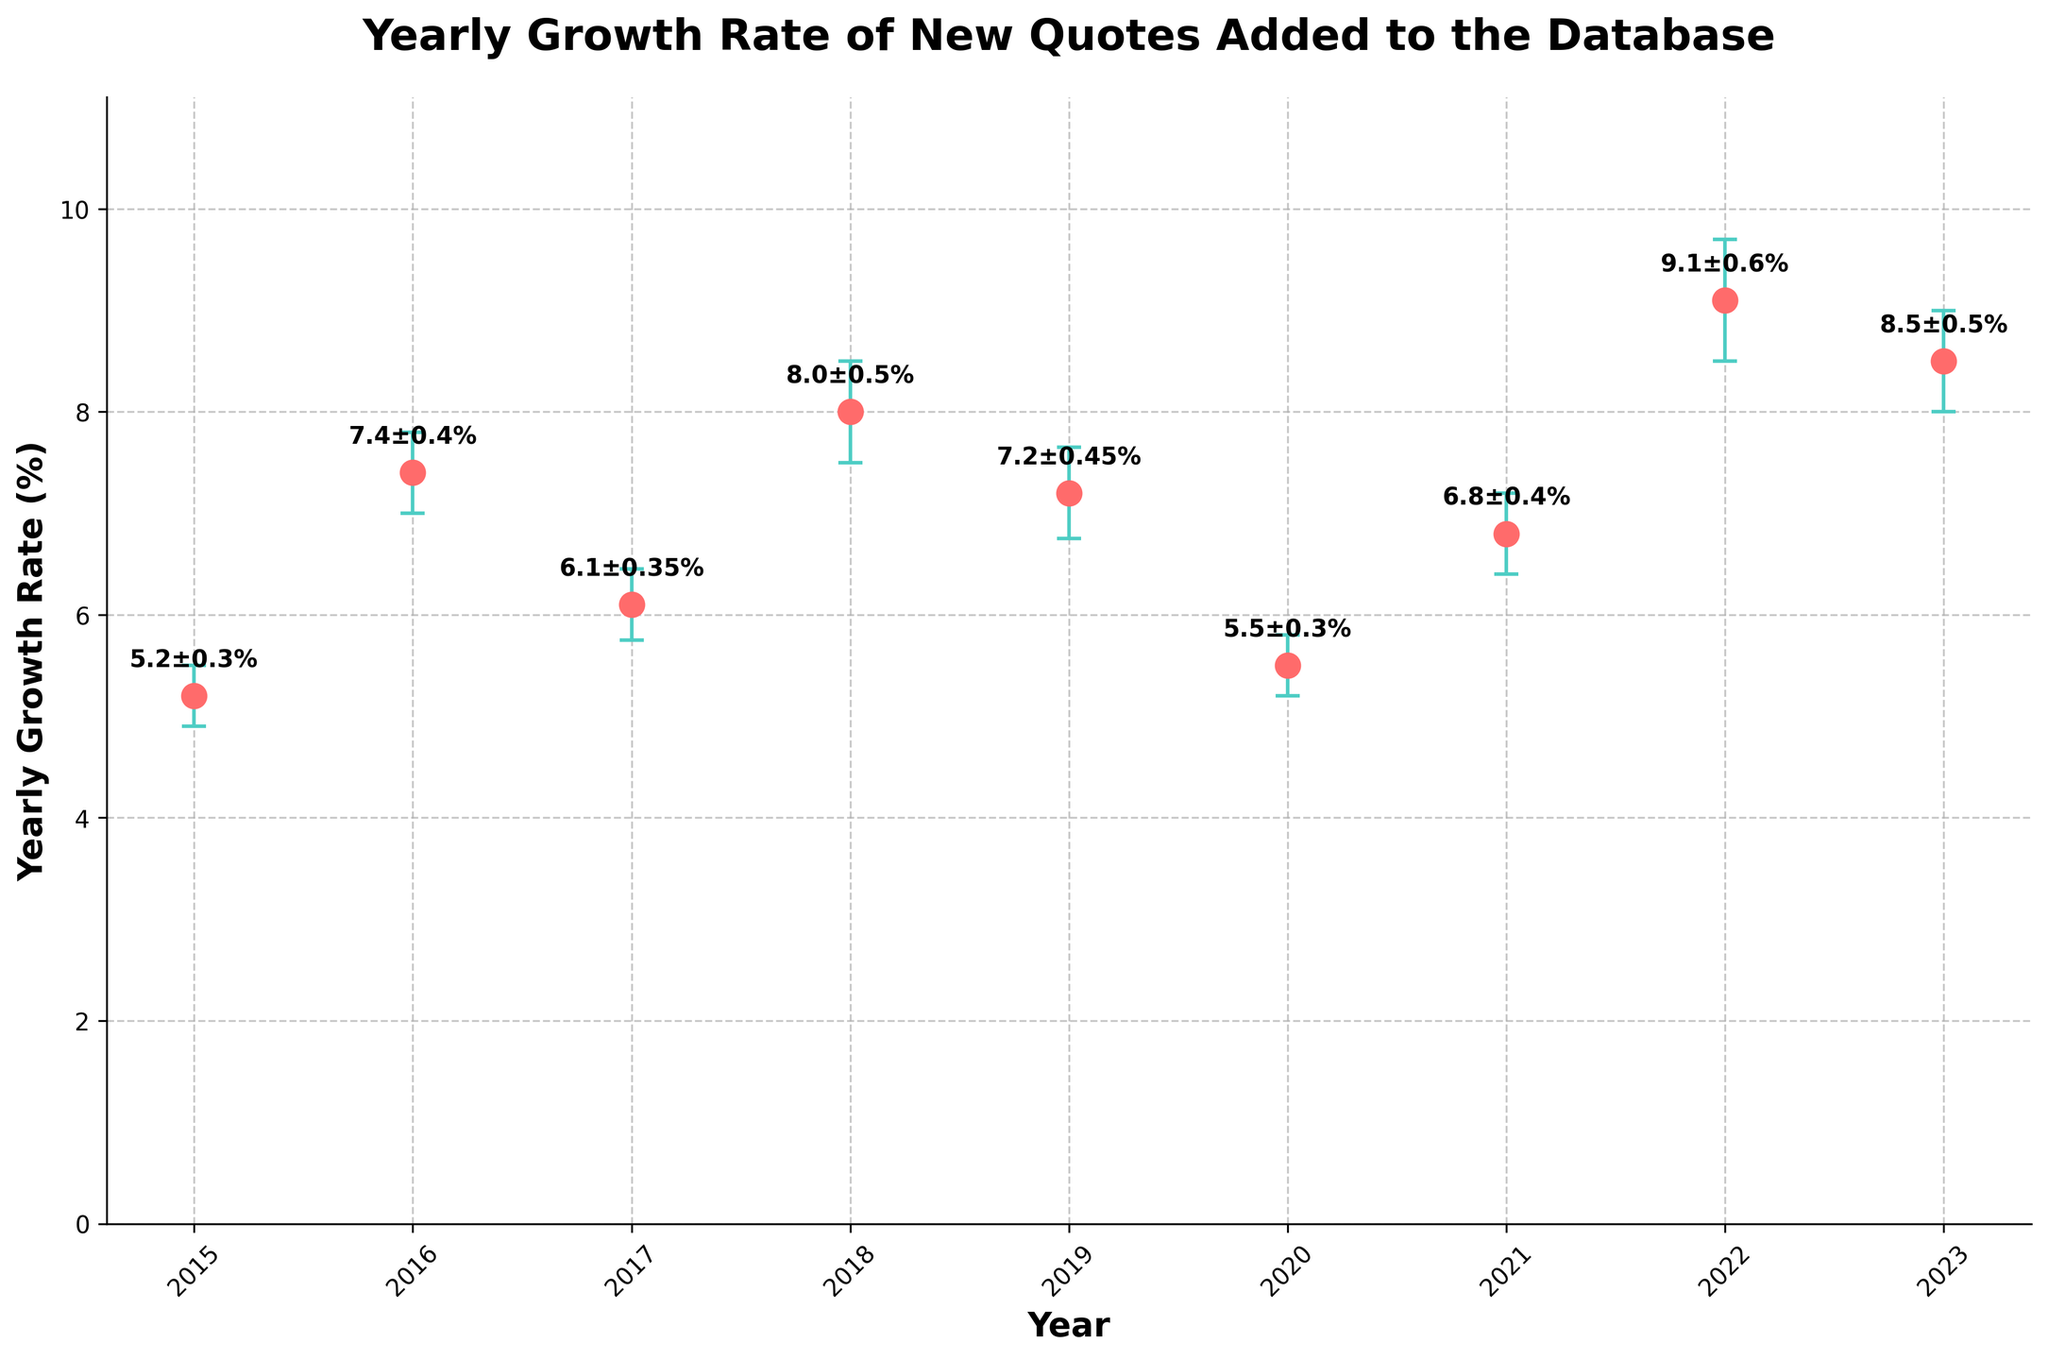What's the title of the figure? The title of the figure is usually displayed at the top of the chart. In this case, it can be seen clearly in large, bold text.
Answer: Yearly Growth Rate of New Quotes Added to the Database What is the yearly growth rate for 2022? To find the yearly growth rate for 2022, look at the data point on the graph that corresponds to the year 2022.
Answer: 9.1% What is the margin of error for 2019? The margin of error for 2019 is indicated by the length of the error bar above and below the point for the year 2019.
Answer: 0.45% Which year experienced the highest growth rate? By comparing the heights of the data points, the highest point indicates the year with the highest growth rate.
Answer: 2022 What is the average yearly growth rate from 2015 to 2023? Sum the yearly growth rates from 2015 to 2023 and then divide by the number of years. (5.2 + 7.4 + 6.1 + 8.0 + 7.2 + 5.5 + 6.8 + 9.1 + 8.5) / 9 = 7.31
Answer: 7.31% How does the growth rate in 2020 compare to that in 2015? To compare the growth rates, subtract the growth rate for 2015 from the growth rate for 2020. 5.5 - 5.2 = 0.3
Answer: 0.3% higher In which year was the margin of error the largest? Look for the longest error bar. The year with the longest error bar has the largest margin of error.
Answer: 2022 What is the range of yearly growth rates from 2015 to 2023? The range is calculated by subtracting the smallest growth rate from the largest growth rate between 2015 and 2023. 9.1 - 5.2 = 3.9
Answer: 3.9% Which years had a growth rate within the margin of error of 7.0%? Check which years have growth rates that, when the margin of error is added or subtracted, include the value 7.0%. 2016 (7.4 ± 0.4), 2019 (7.2 ± 0.45), and 2021 (6.8 ± 0.4) include 7.0% within their margin of error.
Answer: 2016, 2019, 2021 